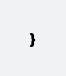Convert code to text. <code><loc_0><loc_0><loc_500><loc_500><_Java_>
}
</code> 